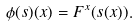<formula> <loc_0><loc_0><loc_500><loc_500>\phi ( s ) ( x ) = F ^ { x } ( s ( x ) ) .</formula> 